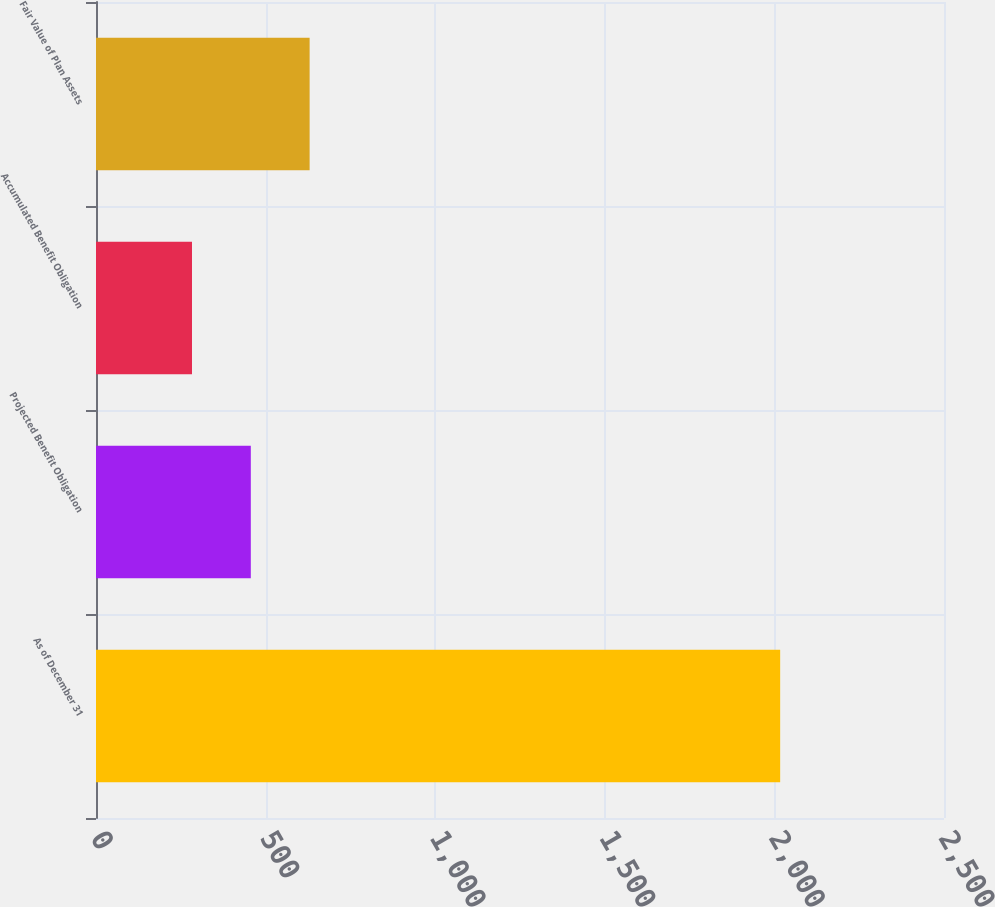Convert chart. <chart><loc_0><loc_0><loc_500><loc_500><bar_chart><fcel>As of December 31<fcel>Projected Benefit Obligation<fcel>Accumulated Benefit Obligation<fcel>Fair Value of Plan Assets<nl><fcel>2017<fcel>456.4<fcel>283<fcel>629.8<nl></chart> 